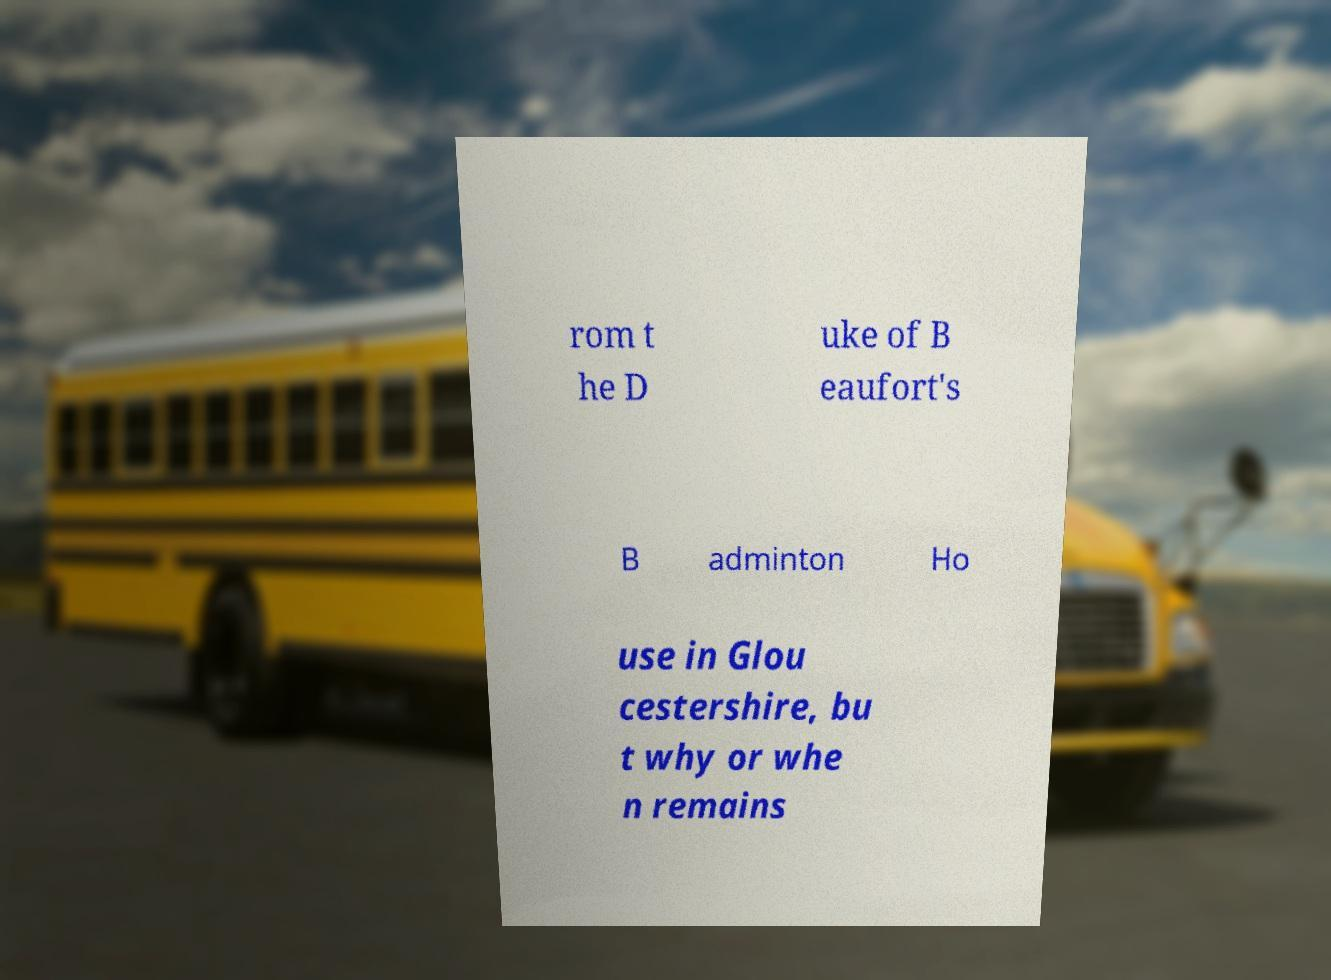I need the written content from this picture converted into text. Can you do that? rom t he D uke of B eaufort's B adminton Ho use in Glou cestershire, bu t why or whe n remains 